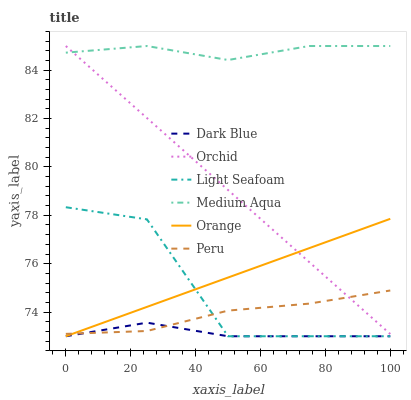Does Dark Blue have the minimum area under the curve?
Answer yes or no. Yes. Does Medium Aqua have the maximum area under the curve?
Answer yes or no. Yes. Does Peru have the minimum area under the curve?
Answer yes or no. No. Does Peru have the maximum area under the curve?
Answer yes or no. No. Is Orange the smoothest?
Answer yes or no. Yes. Is Light Seafoam the roughest?
Answer yes or no. Yes. Is Medium Aqua the smoothest?
Answer yes or no. No. Is Medium Aqua the roughest?
Answer yes or no. No. Does Dark Blue have the lowest value?
Answer yes or no. Yes. Does Peru have the lowest value?
Answer yes or no. No. Does Orchid have the highest value?
Answer yes or no. Yes. Does Peru have the highest value?
Answer yes or no. No. Is Dark Blue less than Orchid?
Answer yes or no. Yes. Is Medium Aqua greater than Peru?
Answer yes or no. Yes. Does Orange intersect Peru?
Answer yes or no. Yes. Is Orange less than Peru?
Answer yes or no. No. Is Orange greater than Peru?
Answer yes or no. No. Does Dark Blue intersect Orchid?
Answer yes or no. No. 